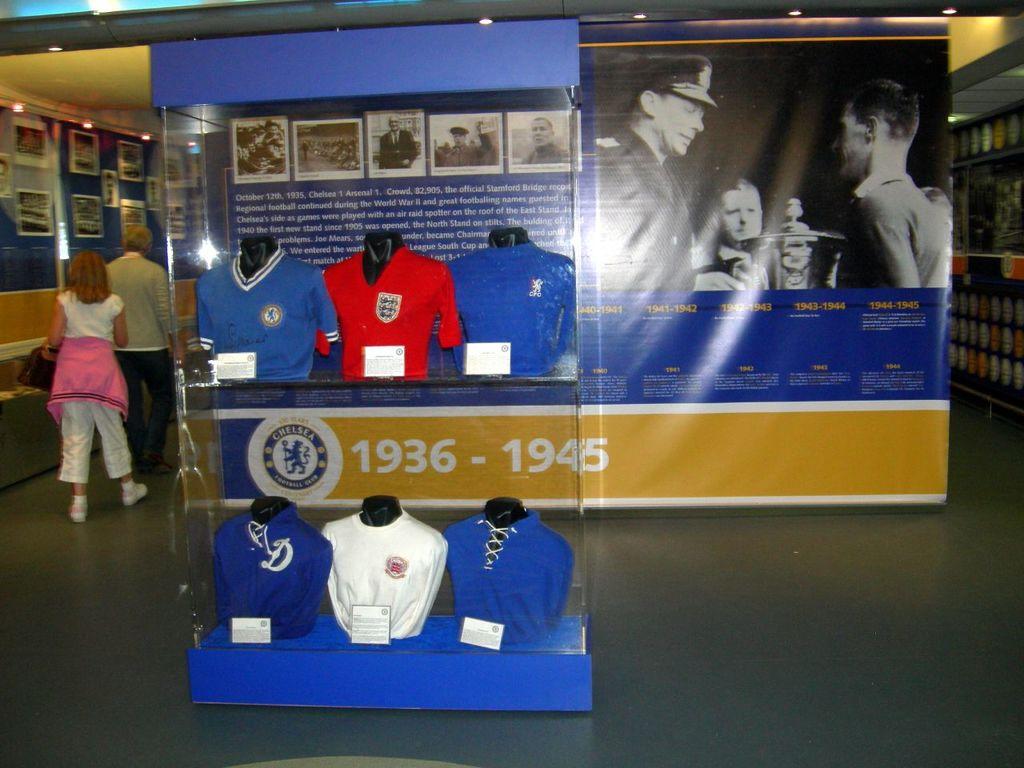Between what years is this display remembering?
Provide a short and direct response. 1936-1945. 